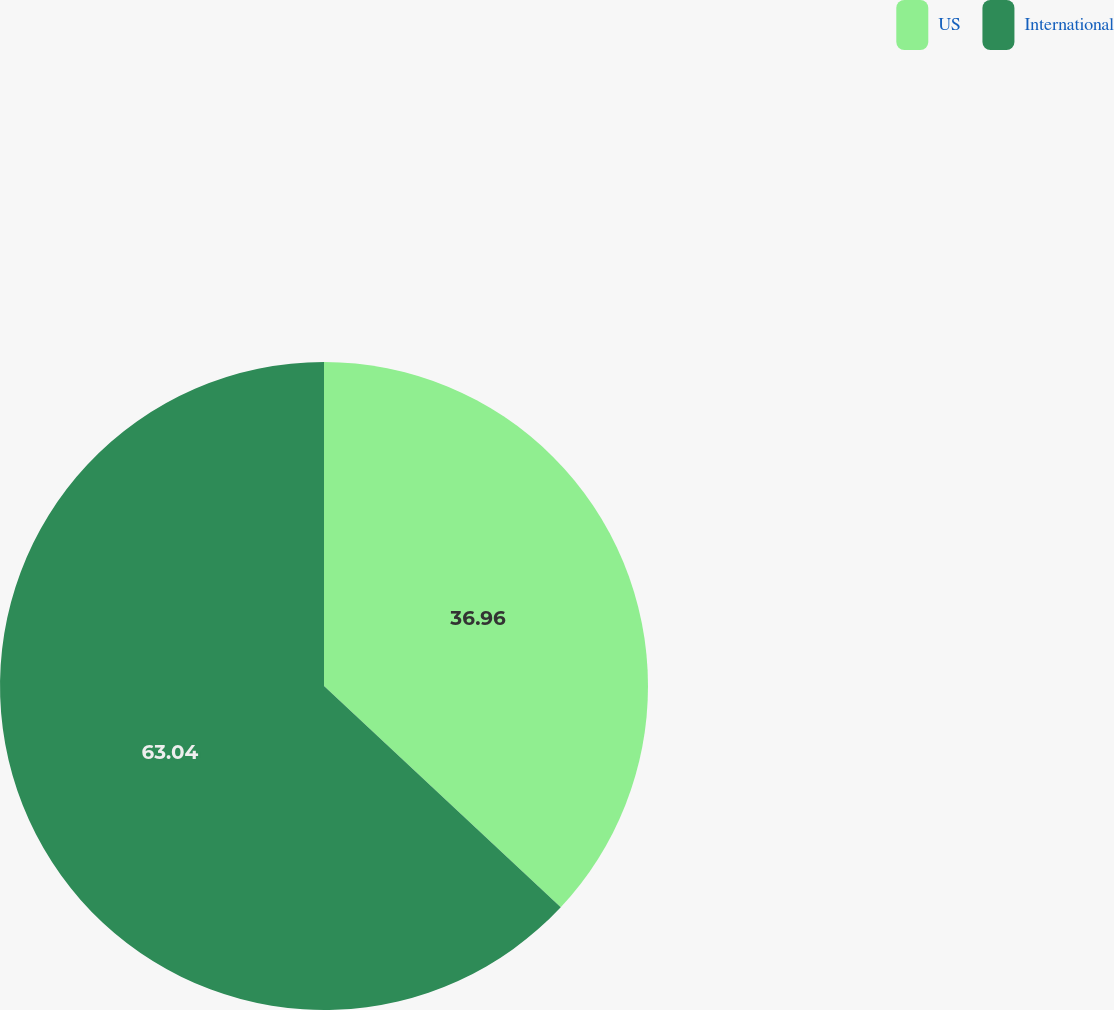<chart> <loc_0><loc_0><loc_500><loc_500><pie_chart><fcel>US<fcel>International<nl><fcel>36.96%<fcel>63.04%<nl></chart> 